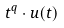Convert formula to latex. <formula><loc_0><loc_0><loc_500><loc_500>t ^ { q } \cdot u ( t )</formula> 